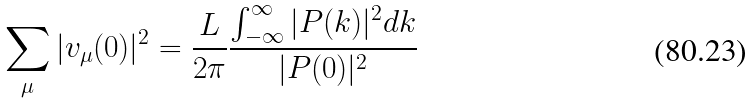Convert formula to latex. <formula><loc_0><loc_0><loc_500><loc_500>\sum _ { \mu } | v _ { \mu } ( 0 ) | ^ { 2 } = \frac { L } { 2 \pi } \frac { \int _ { - \infty } ^ { \infty } | P ( k ) | ^ { 2 } d k } { | P ( 0 ) | ^ { 2 } }</formula> 